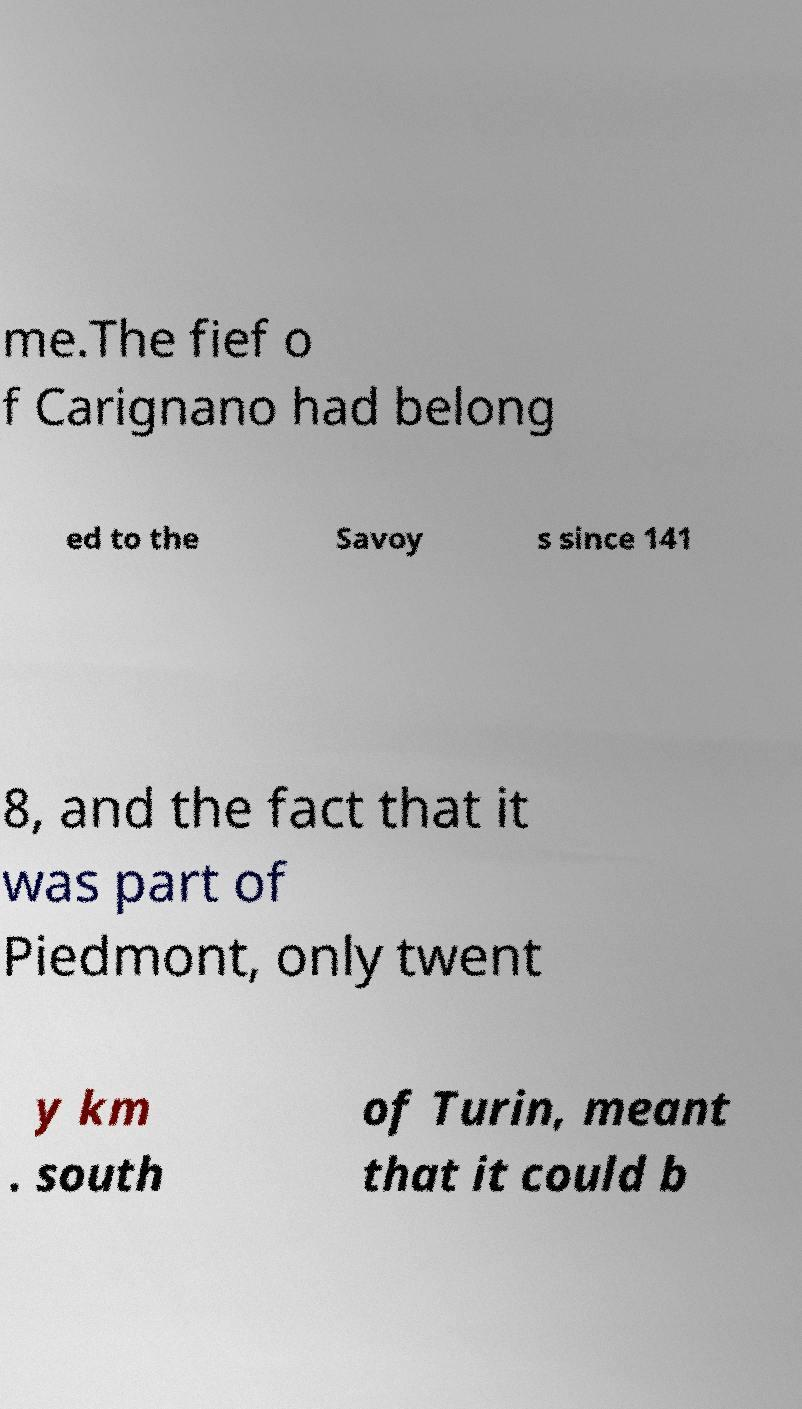Please read and relay the text visible in this image. What does it say? me.The fief o f Carignano had belong ed to the Savoy s since 141 8, and the fact that it was part of Piedmont, only twent y km . south of Turin, meant that it could b 